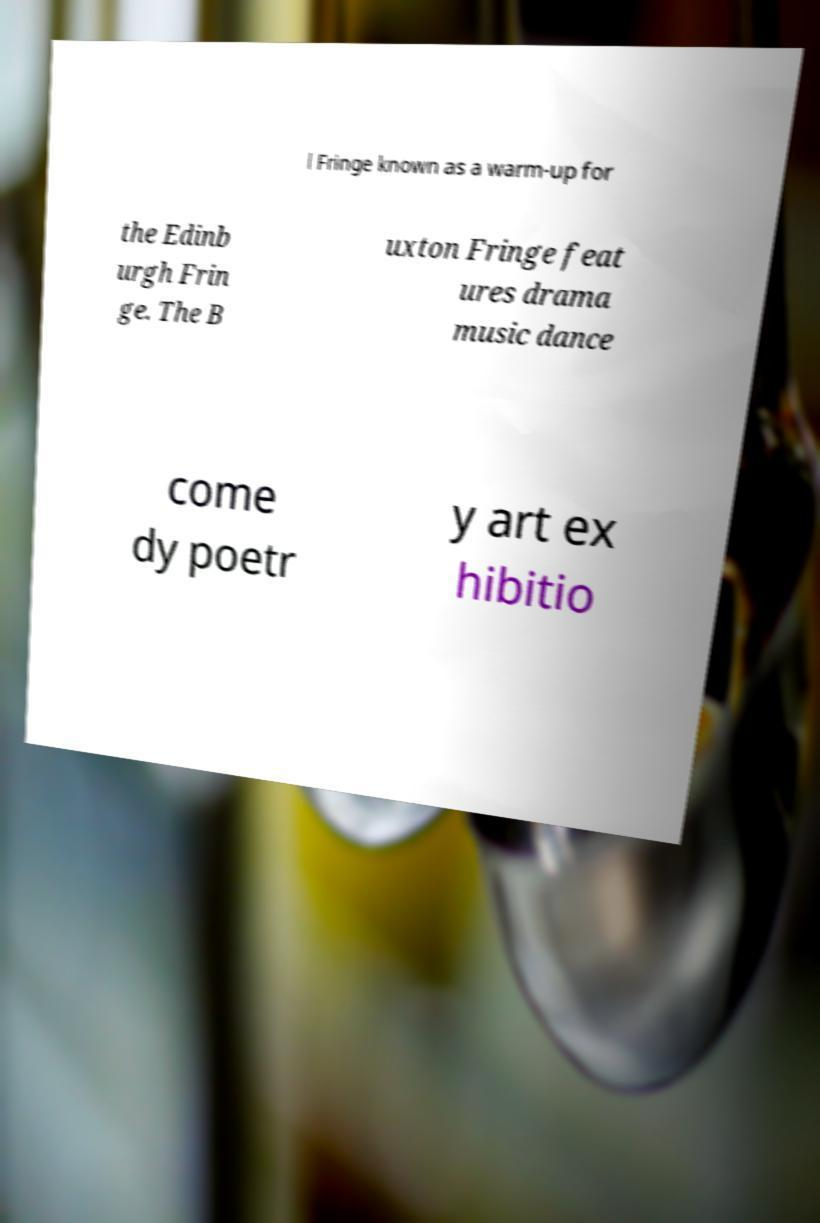What messages or text are displayed in this image? I need them in a readable, typed format. l Fringe known as a warm-up for the Edinb urgh Frin ge. The B uxton Fringe feat ures drama music dance come dy poetr y art ex hibitio 